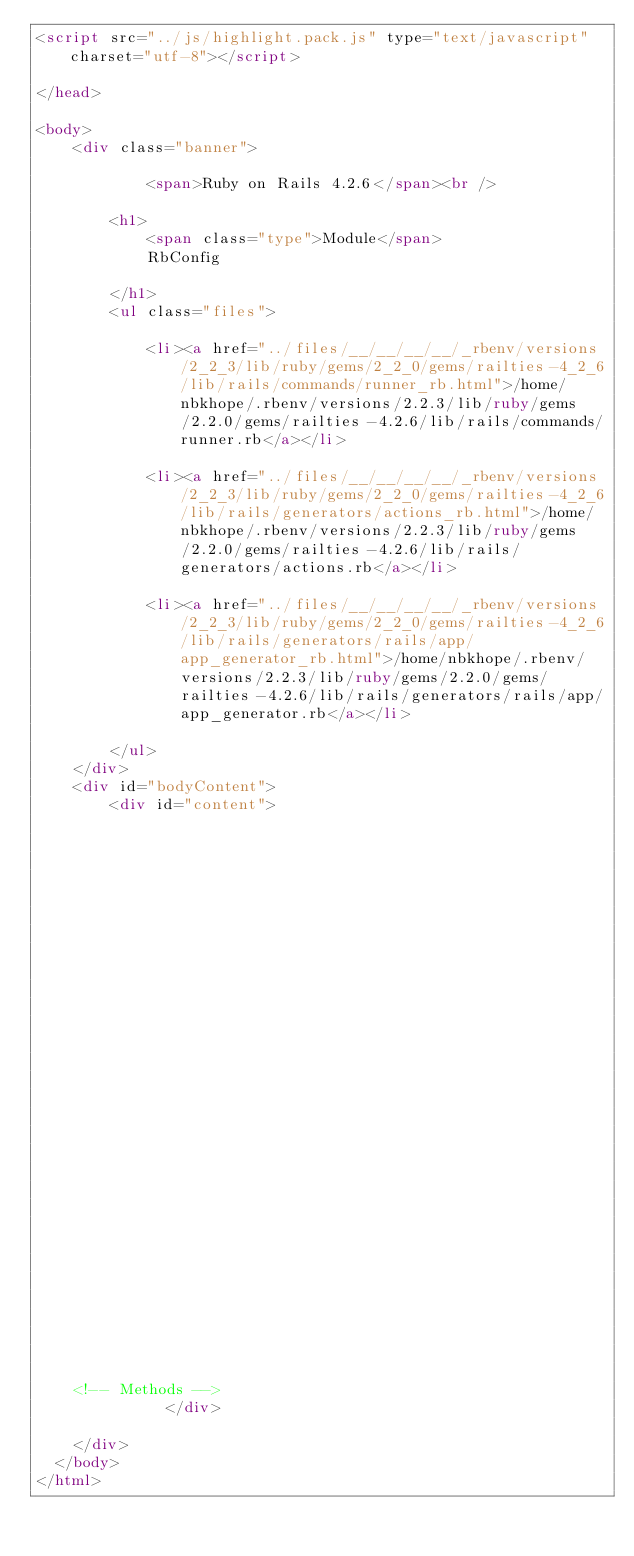Convert code to text. <code><loc_0><loc_0><loc_500><loc_500><_HTML_><script src="../js/highlight.pack.js" type="text/javascript" charset="utf-8"></script>

</head>

<body>     
    <div class="banner">
        
            <span>Ruby on Rails 4.2.6</span><br />
        
        <h1>
            <span class="type">Module</span> 
            RbConfig 
            
        </h1>
        <ul class="files">
            
            <li><a href="../files/__/__/__/__/_rbenv/versions/2_2_3/lib/ruby/gems/2_2_0/gems/railties-4_2_6/lib/rails/commands/runner_rb.html">/home/nbkhope/.rbenv/versions/2.2.3/lib/ruby/gems/2.2.0/gems/railties-4.2.6/lib/rails/commands/runner.rb</a></li>
            
            <li><a href="../files/__/__/__/__/_rbenv/versions/2_2_3/lib/ruby/gems/2_2_0/gems/railties-4_2_6/lib/rails/generators/actions_rb.html">/home/nbkhope/.rbenv/versions/2.2.3/lib/ruby/gems/2.2.0/gems/railties-4.2.6/lib/rails/generators/actions.rb</a></li>
            
            <li><a href="../files/__/__/__/__/_rbenv/versions/2_2_3/lib/ruby/gems/2_2_0/gems/railties-4_2_6/lib/rails/generators/rails/app/app_generator_rb.html">/home/nbkhope/.rbenv/versions/2.2.3/lib/ruby/gems/2.2.0/gems/railties-4.2.6/lib/rails/generators/rails/app/app_generator.rb</a></li>
            
        </ul>
    </div>
    <div id="bodyContent">
        <div id="content">
  


  


  
  


  


  

  



  

    

    

    


    


    <!-- Methods -->
              </div>

    </div>
  </body>
</html>    </code> 